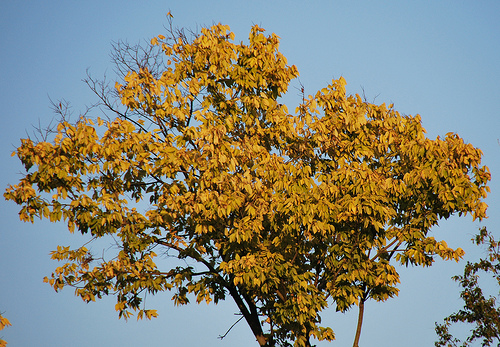<image>
Is the tree behind the sky? No. The tree is not behind the sky. From this viewpoint, the tree appears to be positioned elsewhere in the scene. 